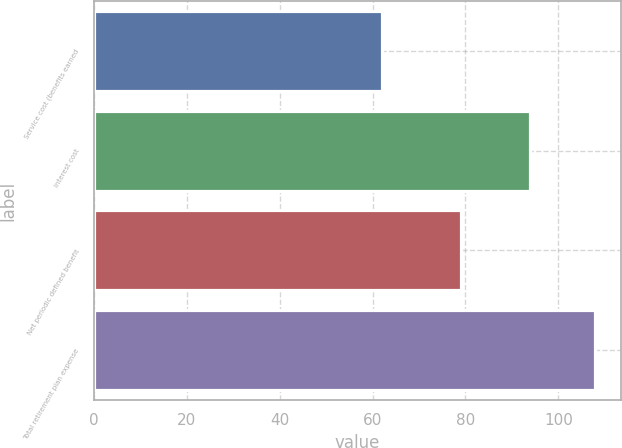Convert chart. <chart><loc_0><loc_0><loc_500><loc_500><bar_chart><fcel>Service cost (benefits earned<fcel>Interest cost<fcel>Net periodic defined benefit<fcel>Total retirement plan expense<nl><fcel>62<fcel>94<fcel>79<fcel>108<nl></chart> 